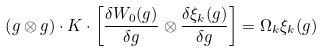Convert formula to latex. <formula><loc_0><loc_0><loc_500><loc_500>\left ( g \otimes g \right ) \cdot K \cdot \left [ \frac { \delta W _ { 0 } ( g ) } { \delta g } \otimes \frac { \delta \xi _ { k } ( g ) } { \delta g } \right ] = \Omega _ { k } \xi _ { k } ( g )</formula> 